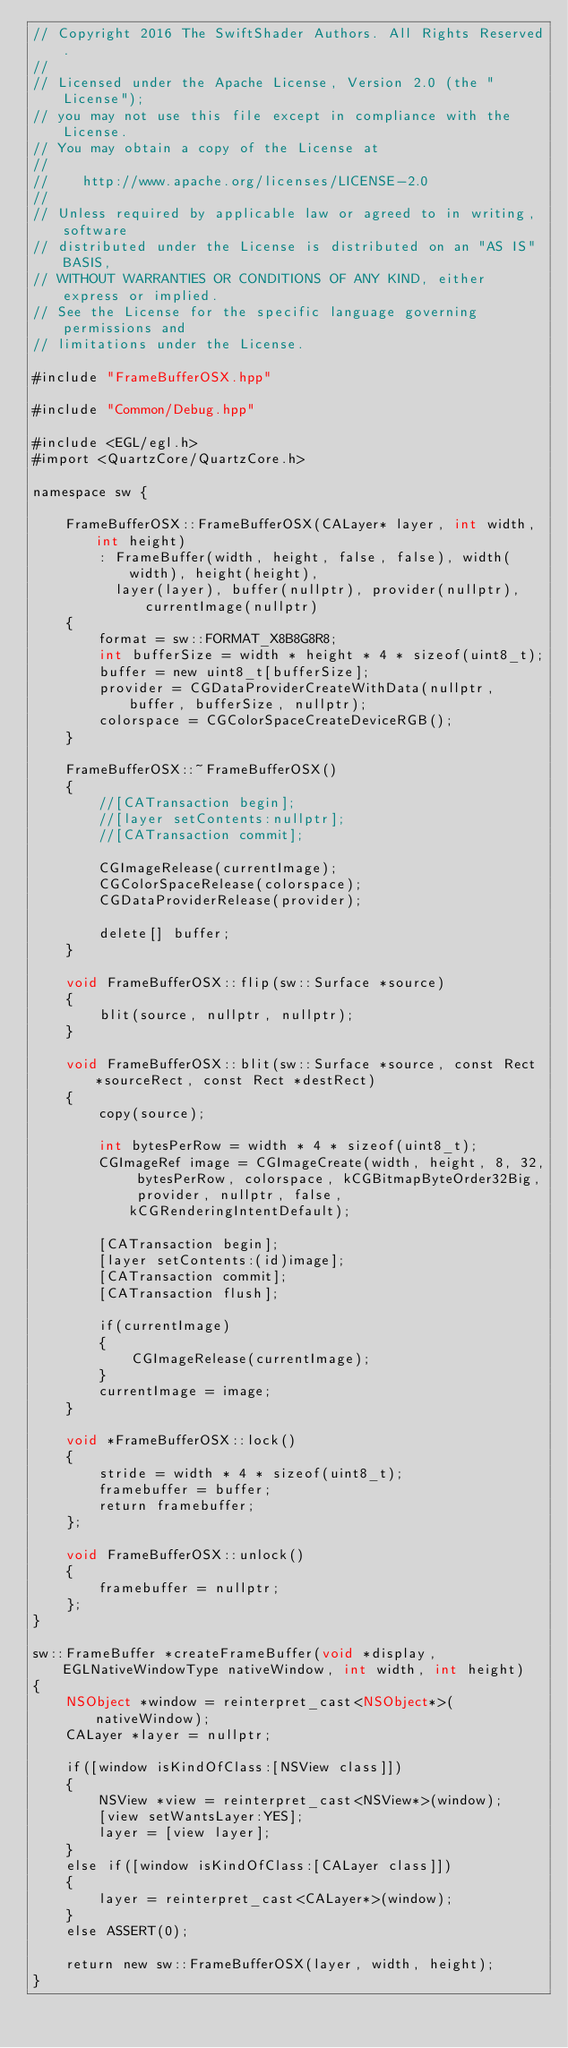<code> <loc_0><loc_0><loc_500><loc_500><_ObjectiveC_>// Copyright 2016 The SwiftShader Authors. All Rights Reserved.
//
// Licensed under the Apache License, Version 2.0 (the "License");
// you may not use this file except in compliance with the License.
// You may obtain a copy of the License at
//
//    http://www.apache.org/licenses/LICENSE-2.0
//
// Unless required by applicable law or agreed to in writing, software
// distributed under the License is distributed on an "AS IS" BASIS,
// WITHOUT WARRANTIES OR CONDITIONS OF ANY KIND, either express or implied.
// See the License for the specific language governing permissions and
// limitations under the License.

#include "FrameBufferOSX.hpp"

#include "Common/Debug.hpp"

#include <EGL/egl.h>
#import <QuartzCore/QuartzCore.h>

namespace sw {

	FrameBufferOSX::FrameBufferOSX(CALayer* layer, int width, int height)
		: FrameBuffer(width, height, false, false), width(width), height(height),
		  layer(layer), buffer(nullptr), provider(nullptr), currentImage(nullptr)
	{
		format = sw::FORMAT_X8B8G8R8;
		int bufferSize = width * height * 4 * sizeof(uint8_t);
		buffer = new uint8_t[bufferSize];
		provider = CGDataProviderCreateWithData(nullptr, buffer, bufferSize, nullptr);
		colorspace = CGColorSpaceCreateDeviceRGB();
	}

	FrameBufferOSX::~FrameBufferOSX()
	{
		//[CATransaction begin];
		//[layer setContents:nullptr];
		//[CATransaction commit];

		CGImageRelease(currentImage);
		CGColorSpaceRelease(colorspace);
		CGDataProviderRelease(provider);

		delete[] buffer;
	}

	void FrameBufferOSX::flip(sw::Surface *source)
	{
		blit(source, nullptr, nullptr);
	}

	void FrameBufferOSX::blit(sw::Surface *source, const Rect *sourceRect, const Rect *destRect)
	{
		copy(source);

		int bytesPerRow = width * 4 * sizeof(uint8_t);
		CGImageRef image = CGImageCreate(width, height, 8, 32, bytesPerRow, colorspace, kCGBitmapByteOrder32Big, provider, nullptr, false, kCGRenderingIntentDefault);

		[CATransaction begin];
		[layer setContents:(id)image];
		[CATransaction commit];
		[CATransaction flush];

		if(currentImage)
		{
			CGImageRelease(currentImage);
		}
		currentImage = image;
	}

	void *FrameBufferOSX::lock()
	{
		stride = width * 4 * sizeof(uint8_t);
		framebuffer = buffer;
		return framebuffer;
	};

	void FrameBufferOSX::unlock()
	{
		framebuffer = nullptr;
	};
}

sw::FrameBuffer *createFrameBuffer(void *display, EGLNativeWindowType nativeWindow, int width, int height)
{
	NSObject *window = reinterpret_cast<NSObject*>(nativeWindow);
	CALayer *layer = nullptr;

	if([window isKindOfClass:[NSView class]])
	{
		NSView *view = reinterpret_cast<NSView*>(window);
		[view setWantsLayer:YES];
		layer = [view layer];
	}
	else if([window isKindOfClass:[CALayer class]])
	{
		layer = reinterpret_cast<CALayer*>(window);
	}
	else ASSERT(0);

	return new sw::FrameBufferOSX(layer, width, height);
}
</code> 